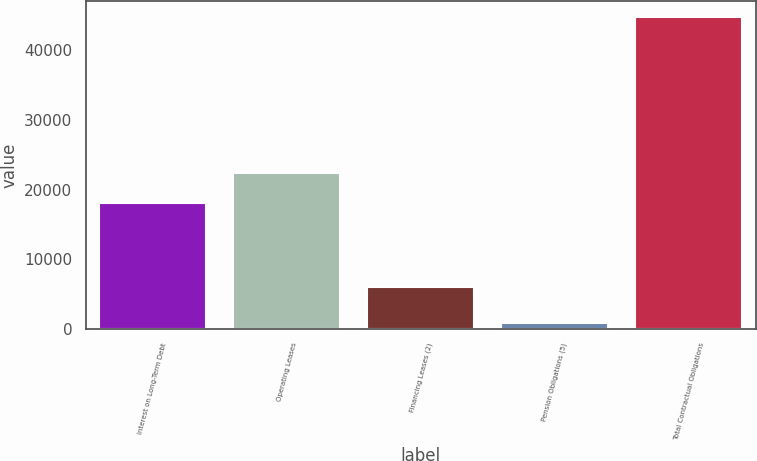Convert chart to OTSL. <chart><loc_0><loc_0><loc_500><loc_500><bar_chart><fcel>Interest on Long-Term Debt<fcel>Operating Leases<fcel>Financing Leases (2)<fcel>Pension Obligations (5)<fcel>Total Contractual Obligations<nl><fcel>18000<fcel>22394.4<fcel>5937<fcel>835<fcel>44779<nl></chart> 